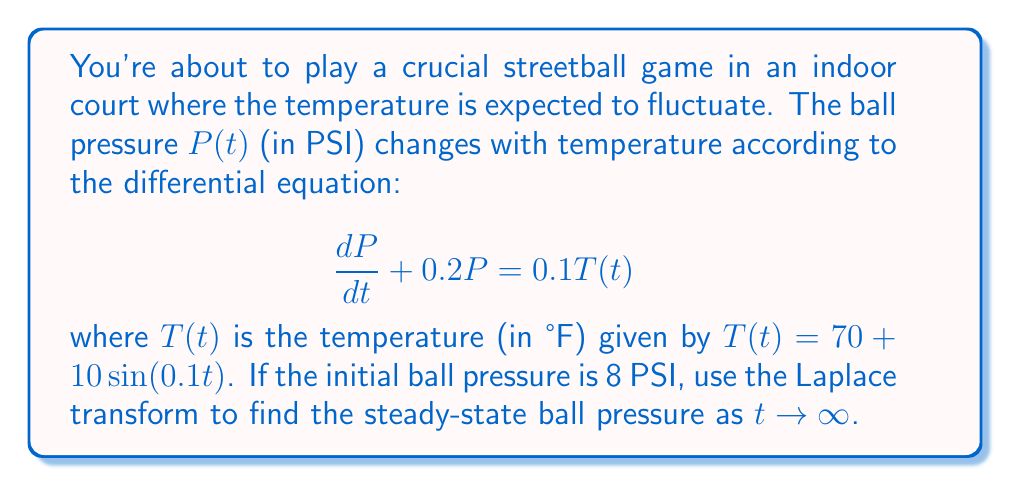Could you help me with this problem? Let's solve this problem step by step using Laplace transforms:

1) First, let's take the Laplace transform of both sides of the differential equation:
   $$\mathcal{L}\{\frac{dP}{dt} + 0.2P\} = \mathcal{L}\{0.1T(t)\}$$

2) Using Laplace transform properties:
   $$sP(s) - P(0) + 0.2P(s) = 0.1\mathcal{L}\{70 + 10\sin(0.1t)\}$$

3) We know that $P(0) = 8$ and $\mathcal{L}\{\sin(at)\} = \frac{a}{s^2+a^2}$, so:
   $$sP(s) - 8 + 0.2P(s) = 0.1(\frac{70}{s} + \frac{1}{s^2+0.01})$$

4) Simplify:
   $$(s+0.2)P(s) = 8 + \frac{7}{s} + \frac{0.1}{s^2+0.01}$$

5) Solve for $P(s)$:
   $$P(s) = \frac{8}{s+0.2} + \frac{7}{s(s+0.2)} + \frac{0.1}{(s+0.2)(s^2+0.01)}$$

6) To find the steady-state solution, we need to apply the Final Value Theorem:
   $$\lim_{t\to\infty} P(t) = \lim_{s\to0} sP(s)$$

7) Apply this to our solution:
   $$\lim_{s\to0} s(\frac{8}{s+0.2} + \frac{7}{s(s+0.2)} + \frac{0.1}{(s+0.2)(s^2+0.01)})$$

8) As $s \to 0$, the first term goes to 0, the second term becomes $\frac{7}{0.2} = 35$, and the third term goes to 0.

Therefore, the steady-state pressure is 35 PSI.
Answer: 35 PSI 